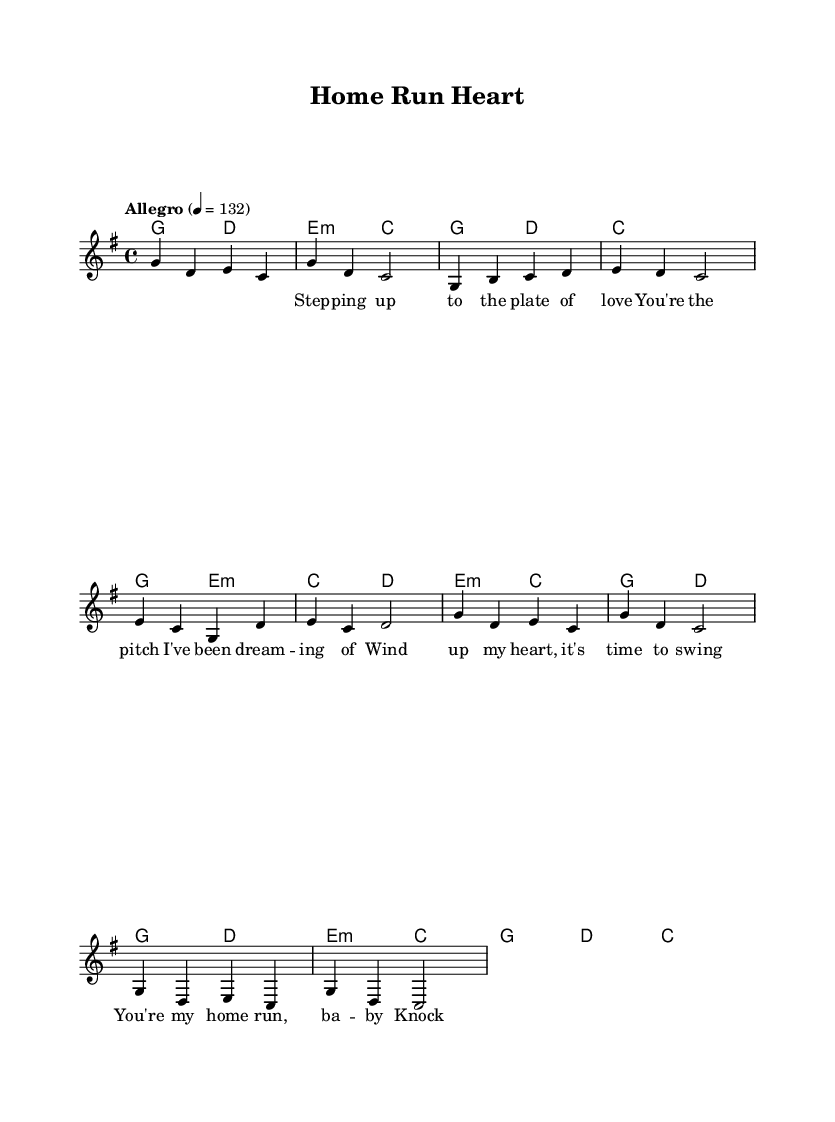What is the key signature of this music? The key signature is G major, which contains one sharp (F#). The clef and the presence of one sharp are indicators of the key.
Answer: G major What is the time signature of this music? The time signature is 4/4, as indicated at the beginning of the sheet music. This means there are four beats per measure, and the quarter note gets one beat.
Answer: 4/4 What is the tempo marking of this music? The tempo marking is "Allegro," which indicates a fast pace, and the specific metronome marking is 132 beats per minute. This can be inferred from the indication placed at the beginning of the score.
Answer: Allegro, 132 How many measures are in the chorus section? The chorus section contains two measures, as indicated in the score. Each measure is separated by a vertical line, and counting the measures in the chorus confirms this.
Answer: 2 What metaphor is used in the lyrics for love? The lyrics compare love to a baseball pitch with phrases like "You're the pitch I've been dreaming of," indicating a baseball metaphor used to describe romance. This comparison incorporates sports imagery which is a common theme in K-Pop.
Answer: Pitch What is the lyrical theme of this song? The lyrical theme revolves around love, using baseball as a metaphor for romantic feelings and experiences, illustrating a playful approach to the subject. The song communicates affection through sports-related imagery, typical of K-Pop’s creative songwriting.
Answer: Love What is the title of the song? The title of the song is "Home Run Heart," which can be found in the header of the sheet music. The name captures the essence of the song's theme, combining love and baseball.
Answer: Home Run Heart 